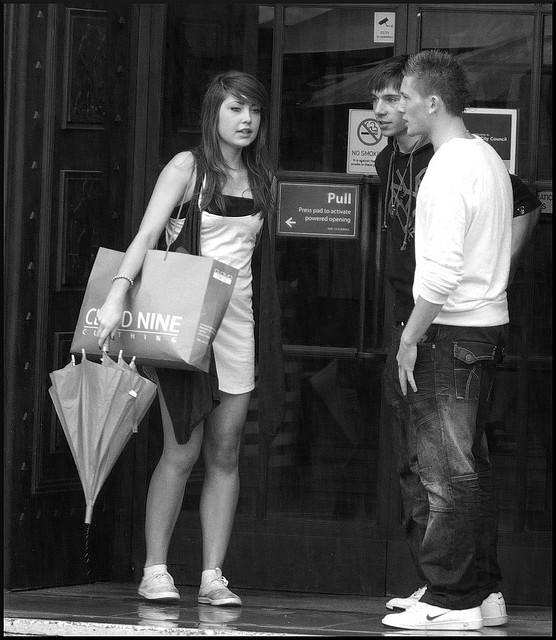What brand of shoes is visible in this photograph?
Be succinct. Nike. Are these people getting reading to go play sports?
Quick response, please. No. What continent is the scene in?
Quick response, please. North america. Are all these people wearing pants?
Answer briefly. No. What is the woman focusing on?
Answer briefly. Street. 